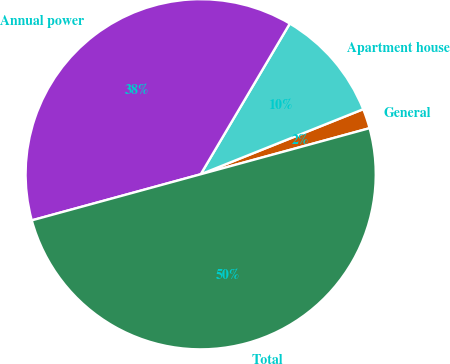Convert chart. <chart><loc_0><loc_0><loc_500><loc_500><pie_chart><fcel>General<fcel>Apartment house<fcel>Annual power<fcel>Total<nl><fcel>1.82%<fcel>10.44%<fcel>37.74%<fcel>50.0%<nl></chart> 